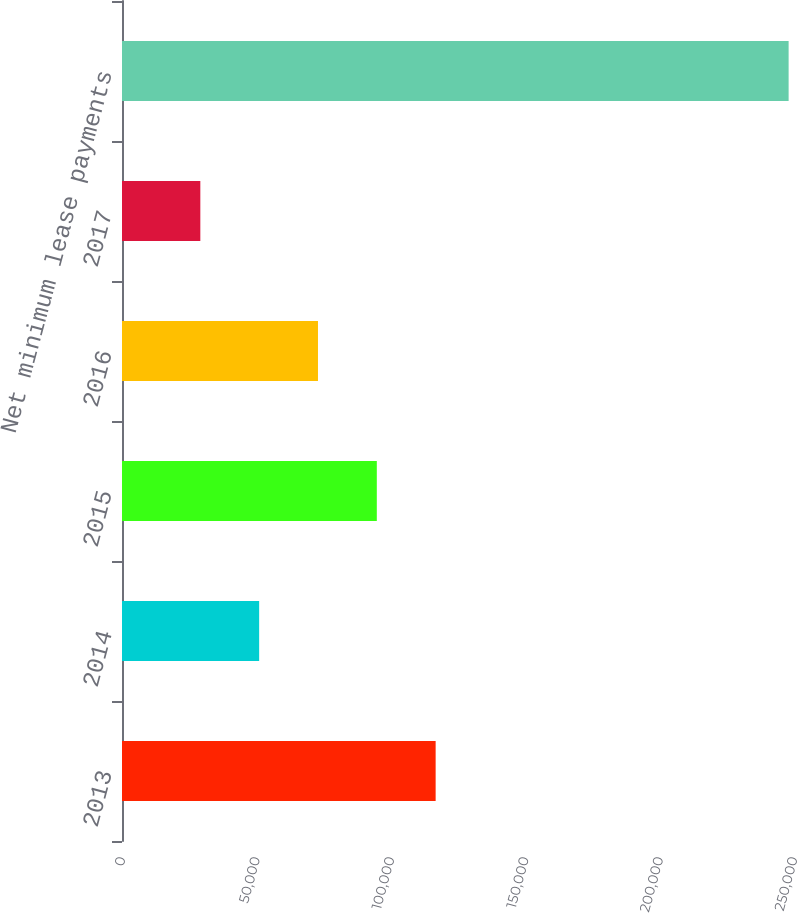<chart> <loc_0><loc_0><loc_500><loc_500><bar_chart><fcel>2013<fcel>2014<fcel>2015<fcel>2016<fcel>2017<fcel>Net minimum lease payments<nl><fcel>116683<fcel>51024.9<fcel>94796.7<fcel>72910.8<fcel>29139<fcel>247998<nl></chart> 